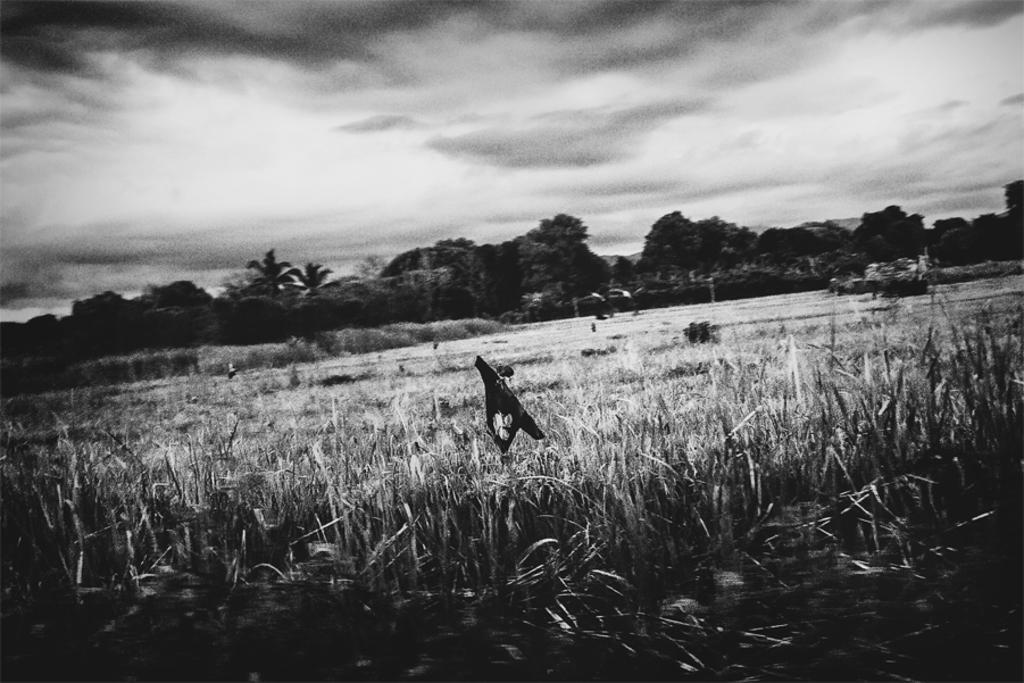Describe this image in one or two sentences. In this image we can see grass and an object looks, like a cloth and in the background there are trees and sky in the top. 